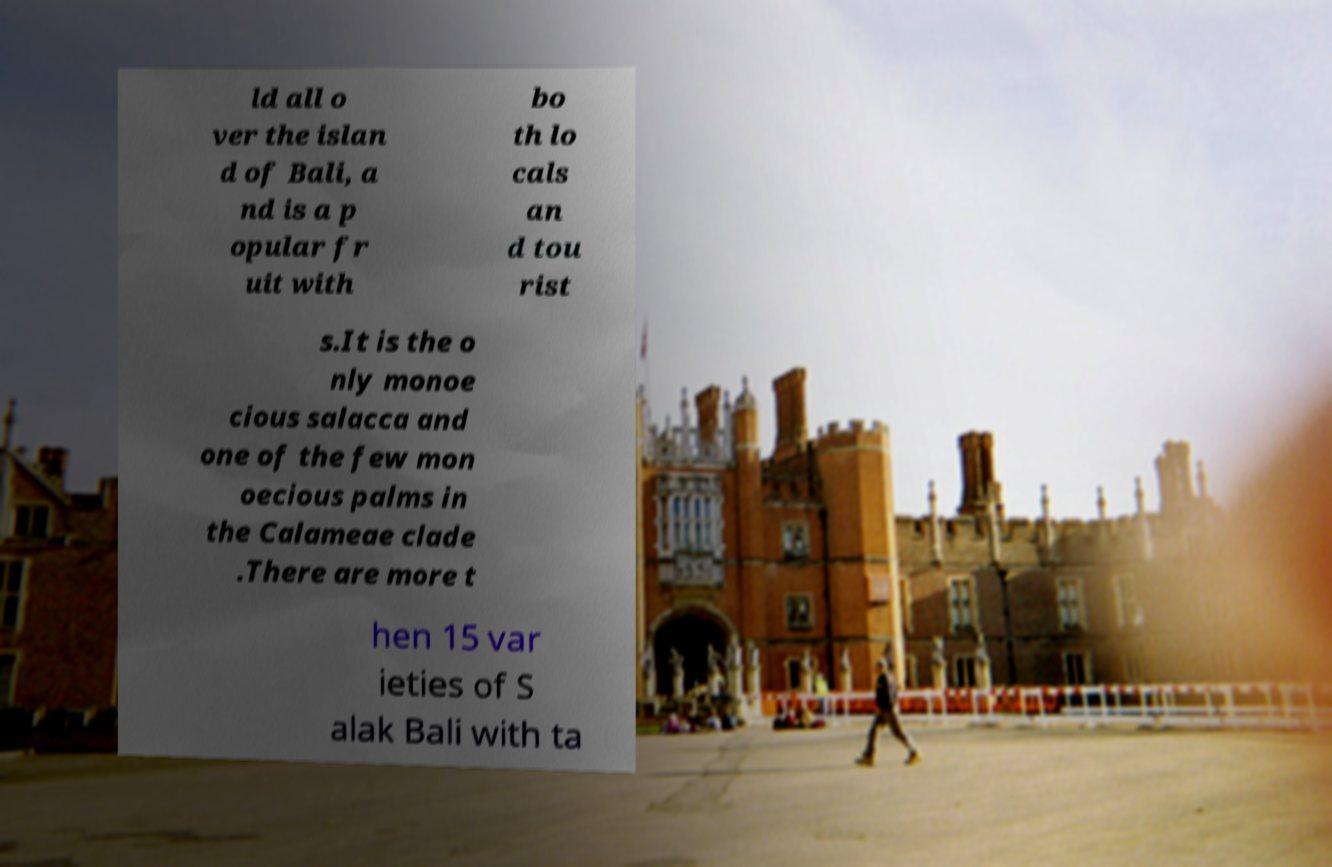There's text embedded in this image that I need extracted. Can you transcribe it verbatim? ld all o ver the islan d of Bali, a nd is a p opular fr uit with bo th lo cals an d tou rist s.It is the o nly monoe cious salacca and one of the few mon oecious palms in the Calameae clade .There are more t hen 15 var ieties of S alak Bali with ta 